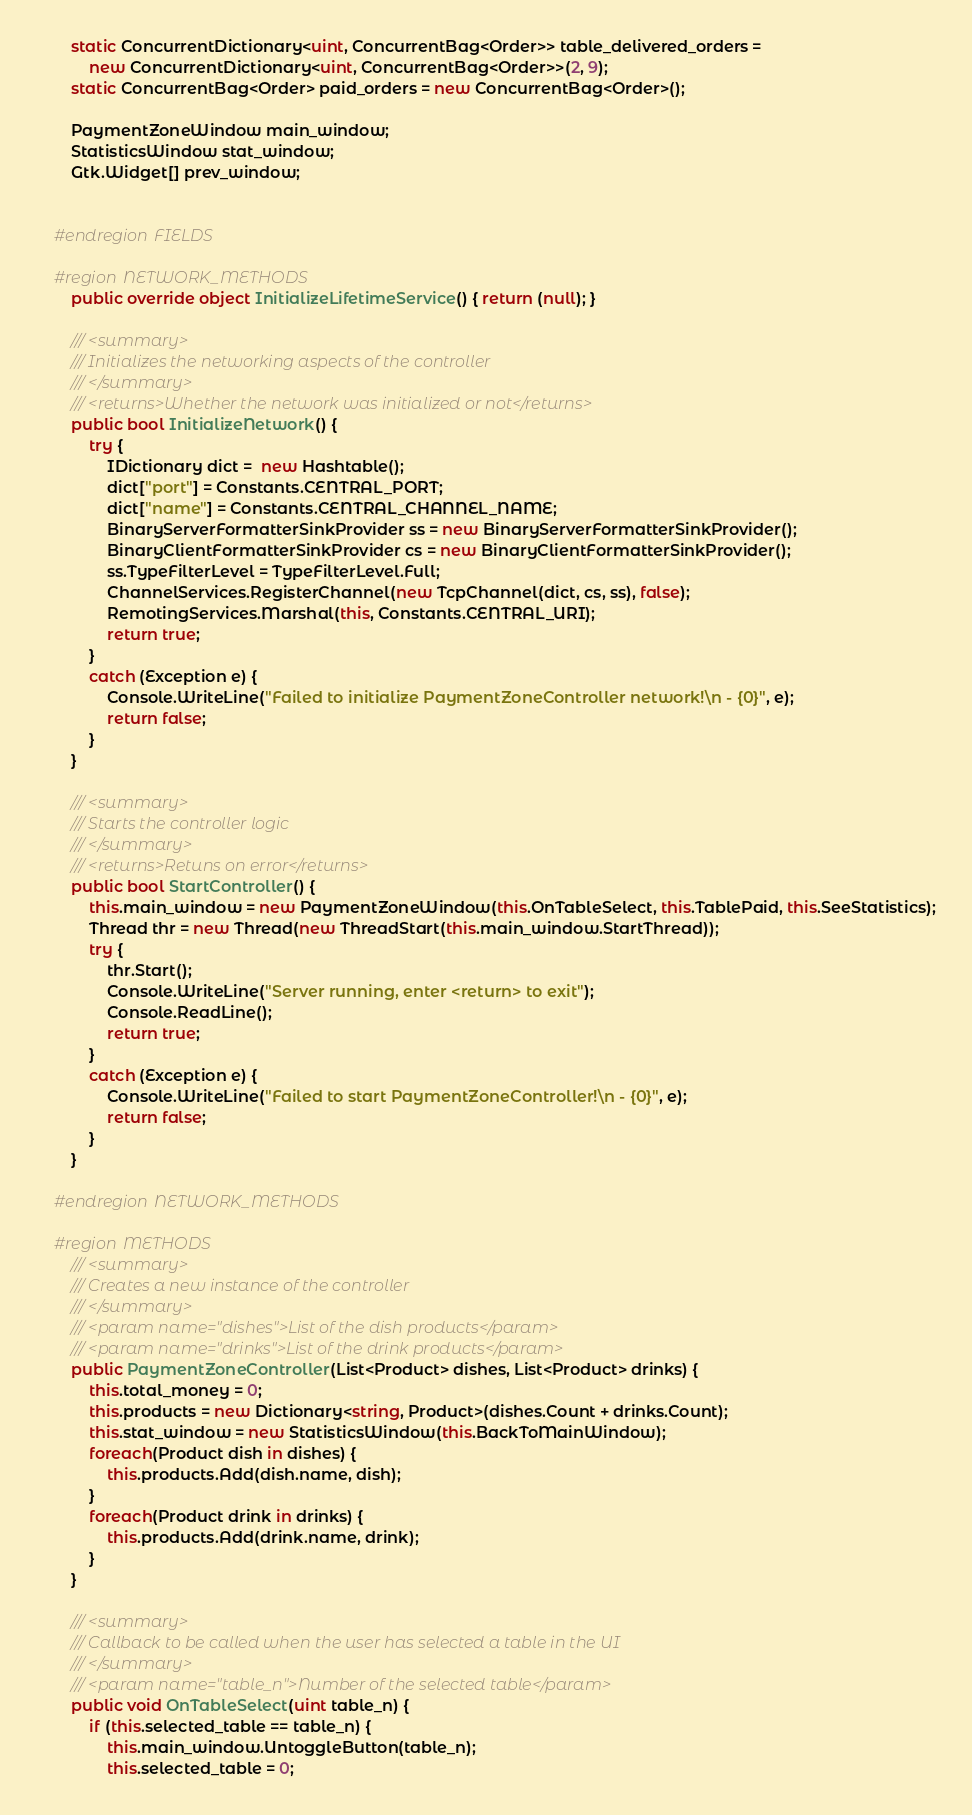Convert code to text. <code><loc_0><loc_0><loc_500><loc_500><_C#_>        static ConcurrentDictionary<uint, ConcurrentBag<Order>> table_delivered_orders = 
            new ConcurrentDictionary<uint, ConcurrentBag<Order>>(2, 9);
        static ConcurrentBag<Order> paid_orders = new ConcurrentBag<Order>();
        
        PaymentZoneWindow main_window;
        StatisticsWindow stat_window;
        Gtk.Widget[] prev_window;
        
    
    #endregion FIELDS

    #region NETWORK_METHODS
        public override object InitializeLifetimeService() { return (null); }

        /// <summary>
        /// Initializes the networking aspects of the controller
        /// </summary>
        /// <returns>Whether the network was initialized or not</returns>
        public bool InitializeNetwork() {
            try {
                IDictionary dict =  new Hashtable();
                dict["port"] = Constants.CENTRAL_PORT;
                dict["name"] = Constants.CENTRAL_CHANNEL_NAME;
                BinaryServerFormatterSinkProvider ss = new BinaryServerFormatterSinkProvider();
                BinaryClientFormatterSinkProvider cs = new BinaryClientFormatterSinkProvider();
                ss.TypeFilterLevel = TypeFilterLevel.Full;
                ChannelServices.RegisterChannel(new TcpChannel(dict, cs, ss), false);
                RemotingServices.Marshal(this, Constants.CENTRAL_URI);
                return true;
            }
            catch (Exception e) {
                Console.WriteLine("Failed to initialize PaymentZoneController network!\n - {0}", e);
                return false;
            }
        }

        /// <summary>
        /// Starts the controller logic
        /// </summary>
        /// <returns>Retuns on error</returns>
        public bool StartController() {
            this.main_window = new PaymentZoneWindow(this.OnTableSelect, this.TablePaid, this.SeeStatistics);
            Thread thr = new Thread(new ThreadStart(this.main_window.StartThread));
            try {
                thr.Start();
                Console.WriteLine("Server running, enter <return> to exit");
                Console.ReadLine();
                return true;
            }
            catch (Exception e) {
                Console.WriteLine("Failed to start PaymentZoneController!\n - {0}", e);
                return false;
            }
        }

    #endregion NETWORK_METHODS

    #region METHODS
        /// <summary>
        /// Creates a new instance of the controller
        /// </summary>
        /// <param name="dishes">List of the dish products</param>
        /// <param name="drinks">List of the drink products</param>
        public PaymentZoneController(List<Product> dishes, List<Product> drinks) {
            this.total_money = 0;
            this.products = new Dictionary<string, Product>(dishes.Count + drinks.Count);
            this.stat_window = new StatisticsWindow(this.BackToMainWindow);
            foreach(Product dish in dishes) {
                this.products.Add(dish.name, dish);
            }
            foreach(Product drink in drinks) {
                this.products.Add(drink.name, drink);
            }
        }

        /// <summary>
        /// Callback to be called when the user has selected a table in the UI
        /// </summary>
        /// <param name="table_n">Number of the selected table</param>
        public void OnTableSelect(uint table_n) {
            if (this.selected_table == table_n) {
                this.main_window.UntoggleButton(table_n);
                this.selected_table = 0;</code> 